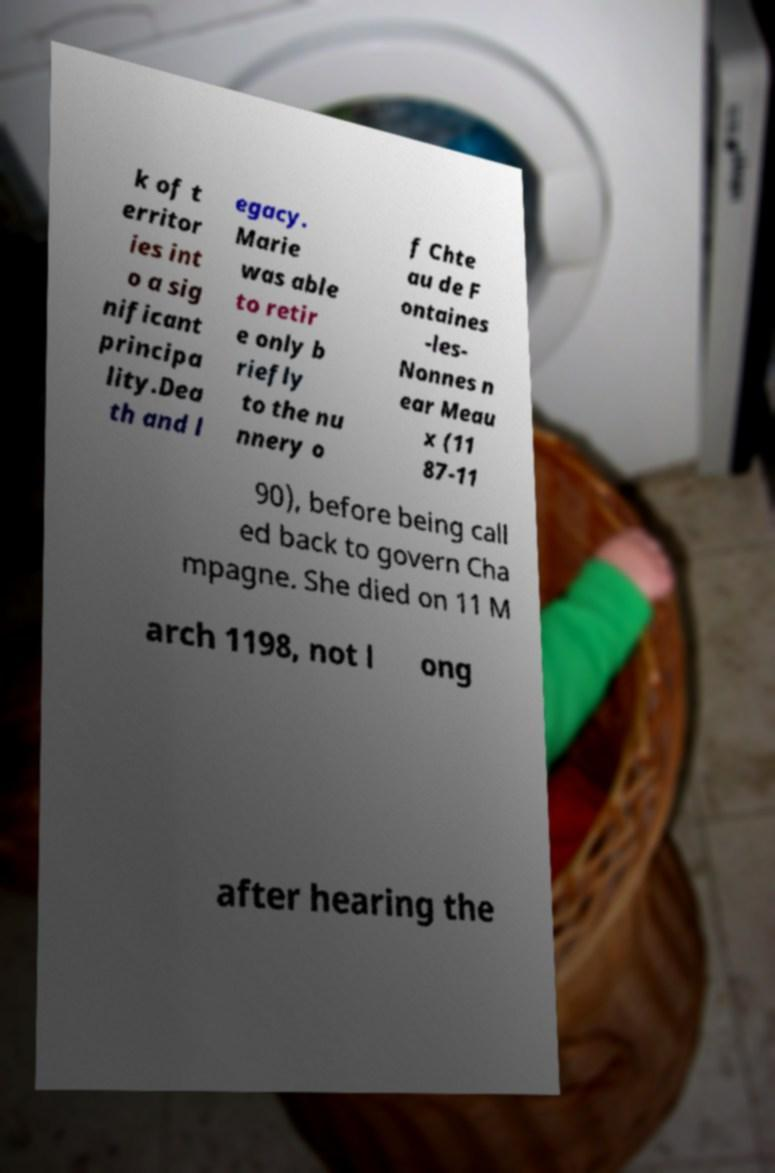Please read and relay the text visible in this image. What does it say? k of t erritor ies int o a sig nificant principa lity.Dea th and l egacy. Marie was able to retir e only b riefly to the nu nnery o f Chte au de F ontaines -les- Nonnes n ear Meau x (11 87-11 90), before being call ed back to govern Cha mpagne. She died on 11 M arch 1198, not l ong after hearing the 